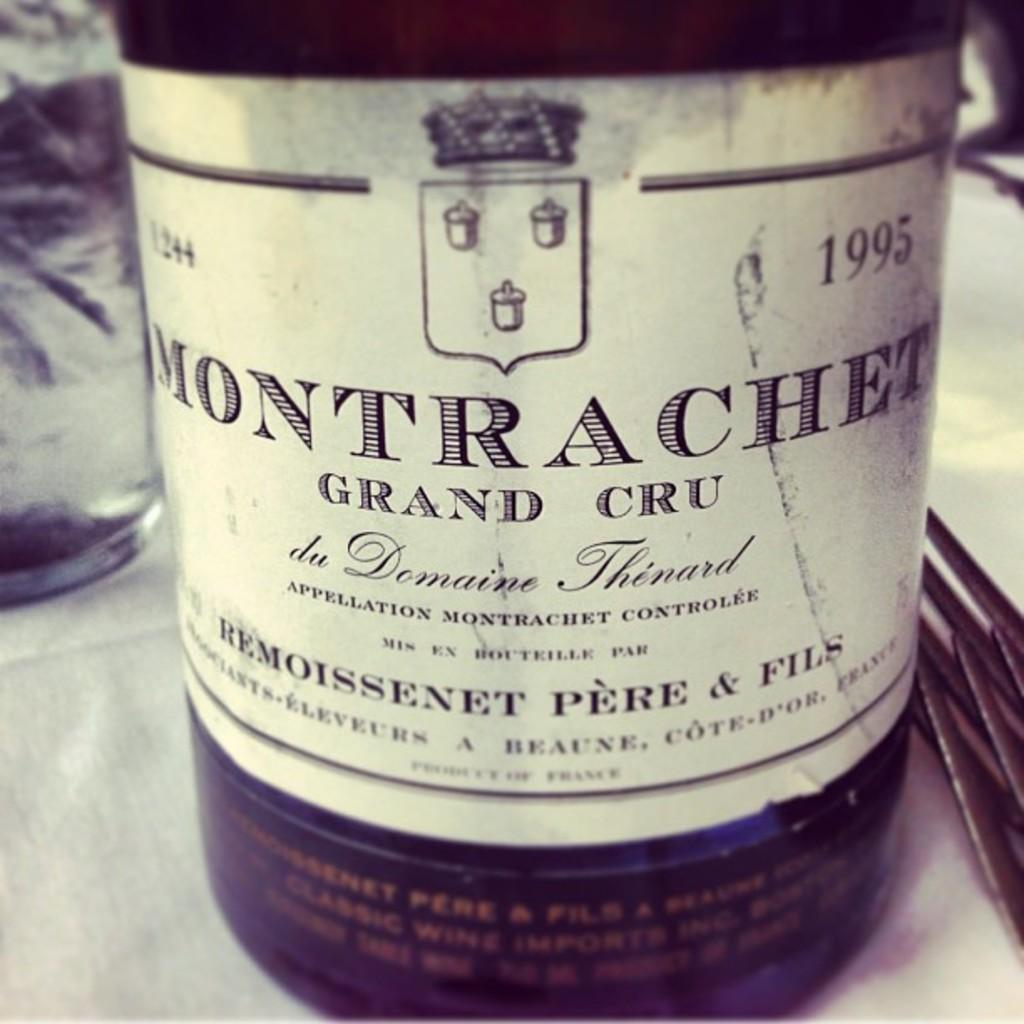Provide a one-sentence caption for the provided image. A bottle that has the labeling date of 1995. 